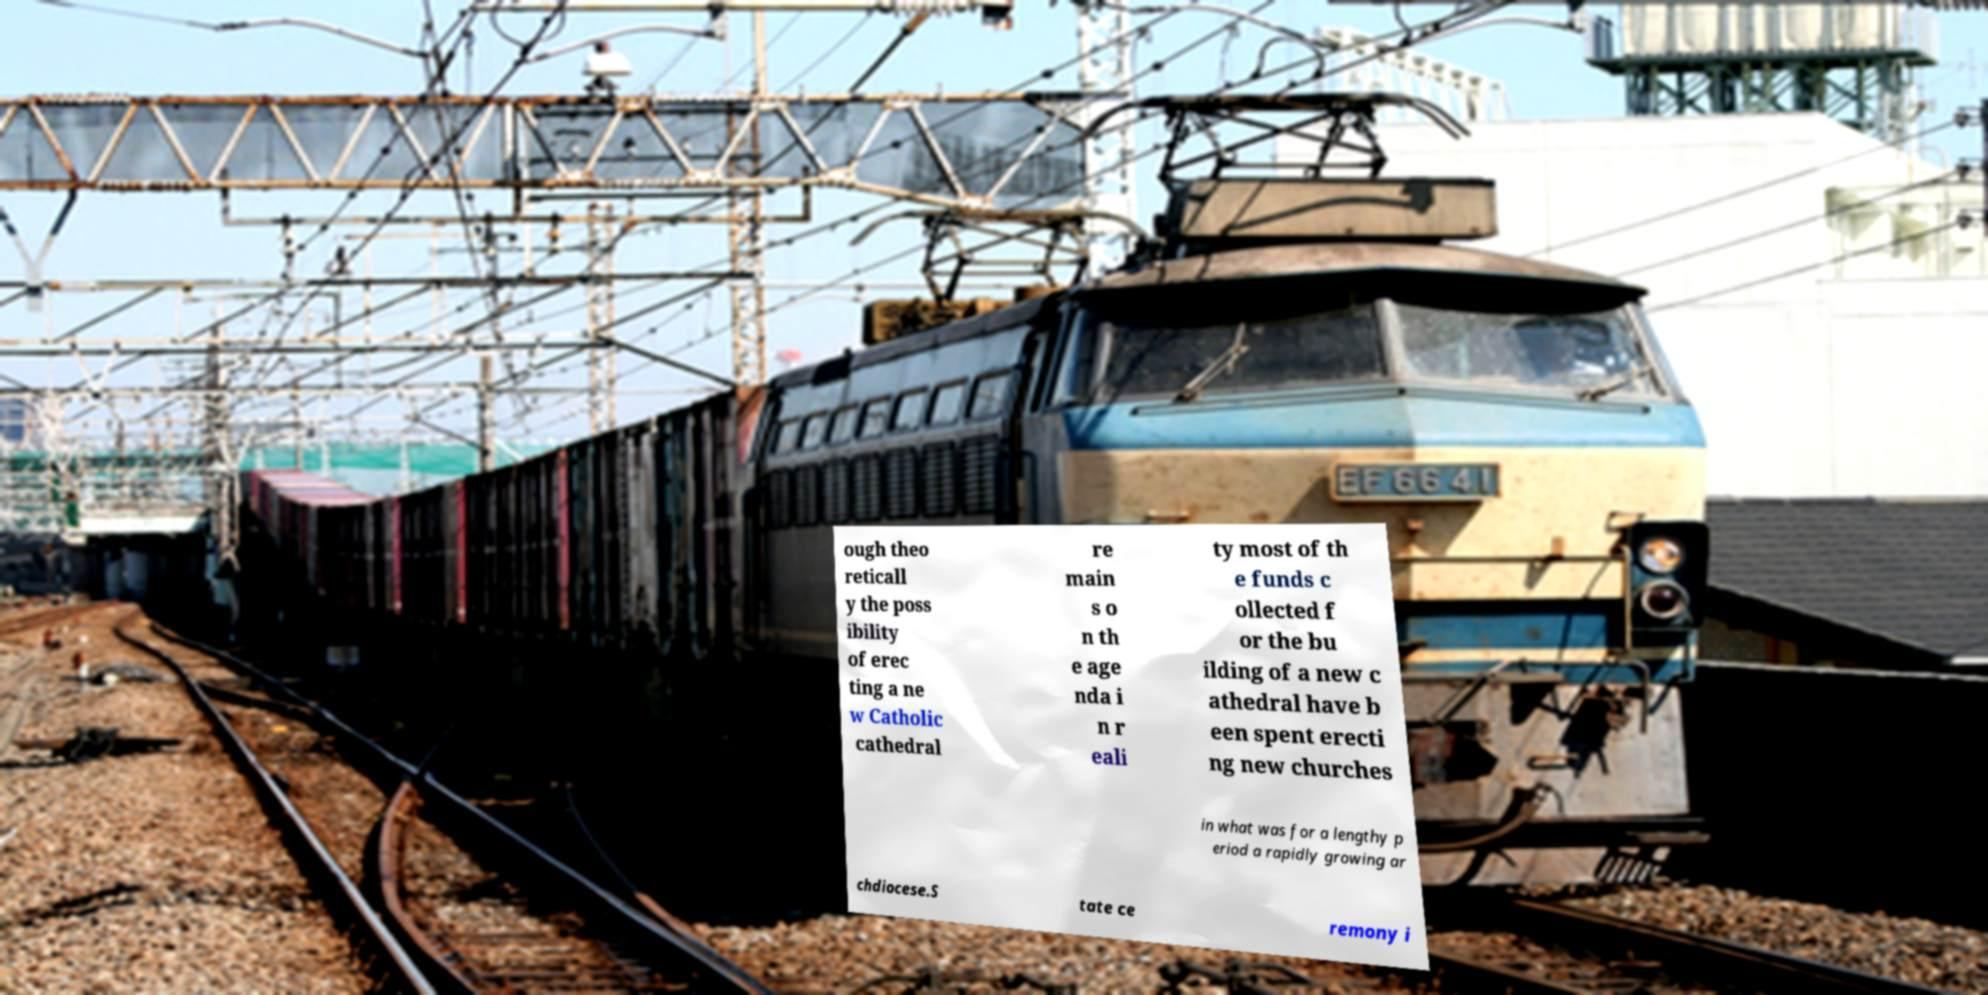Could you extract and type out the text from this image? ough theo reticall y the poss ibility of erec ting a ne w Catholic cathedral re main s o n th e age nda i n r eali ty most of th e funds c ollected f or the bu ilding of a new c athedral have b een spent erecti ng new churches in what was for a lengthy p eriod a rapidly growing ar chdiocese.S tate ce remony i 